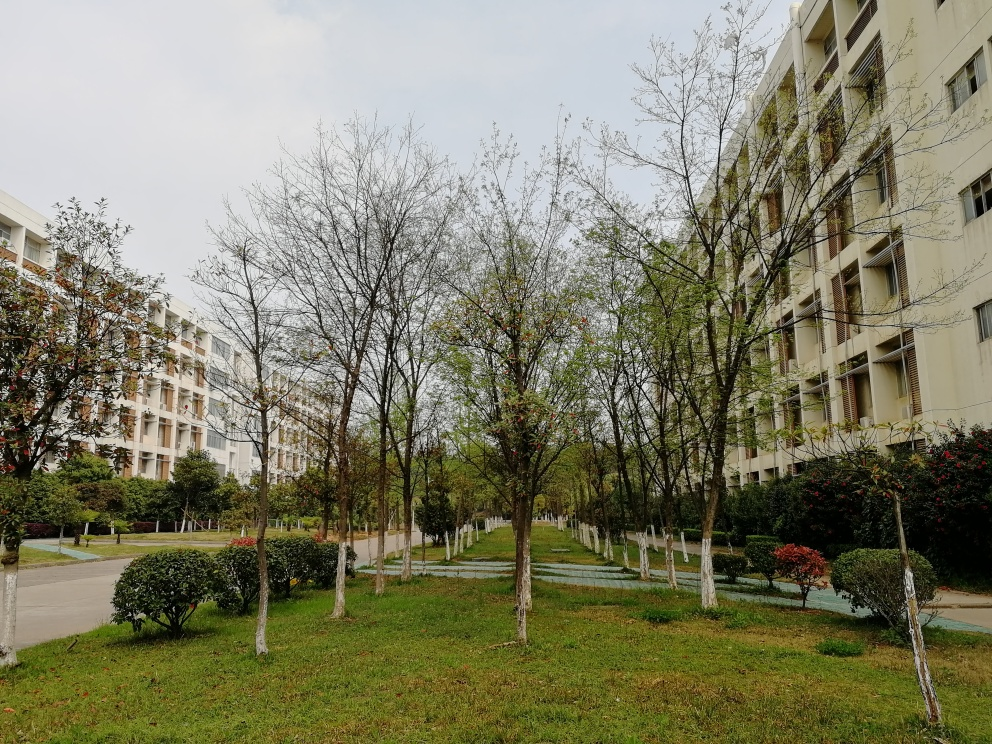Can you describe the mood or atmosphere conveyed by this setting? The setting conveys a tranquil and calm atmosphere. The overcast sky gives an even, soft light across the housing area and the neatly organized landscape suggests a serene and well-maintained environment. The absence of active human presence reinforces the sense of quietness. 